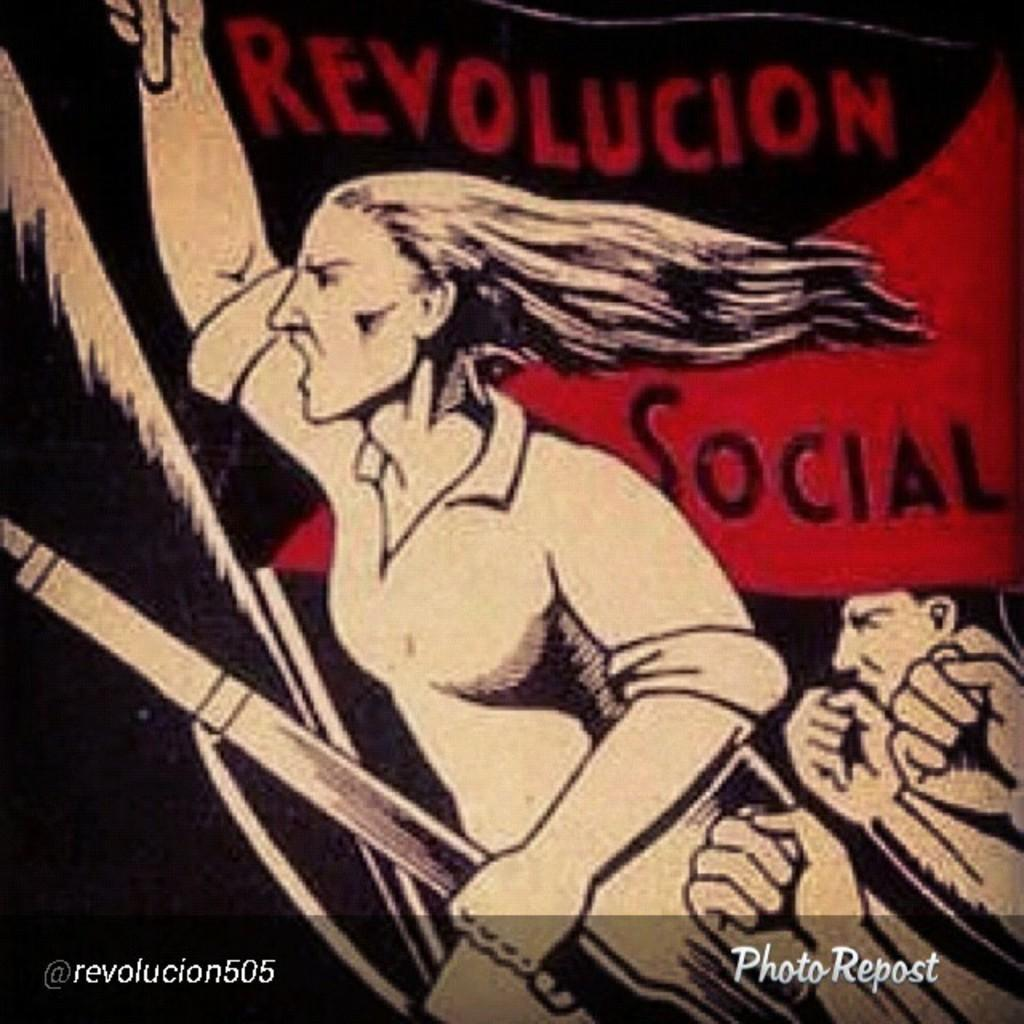Provide a one-sentence caption for the provided image. A large woman carries a rifle in one hand and has her other arm raised high in an image calling for Revolucion Social. 